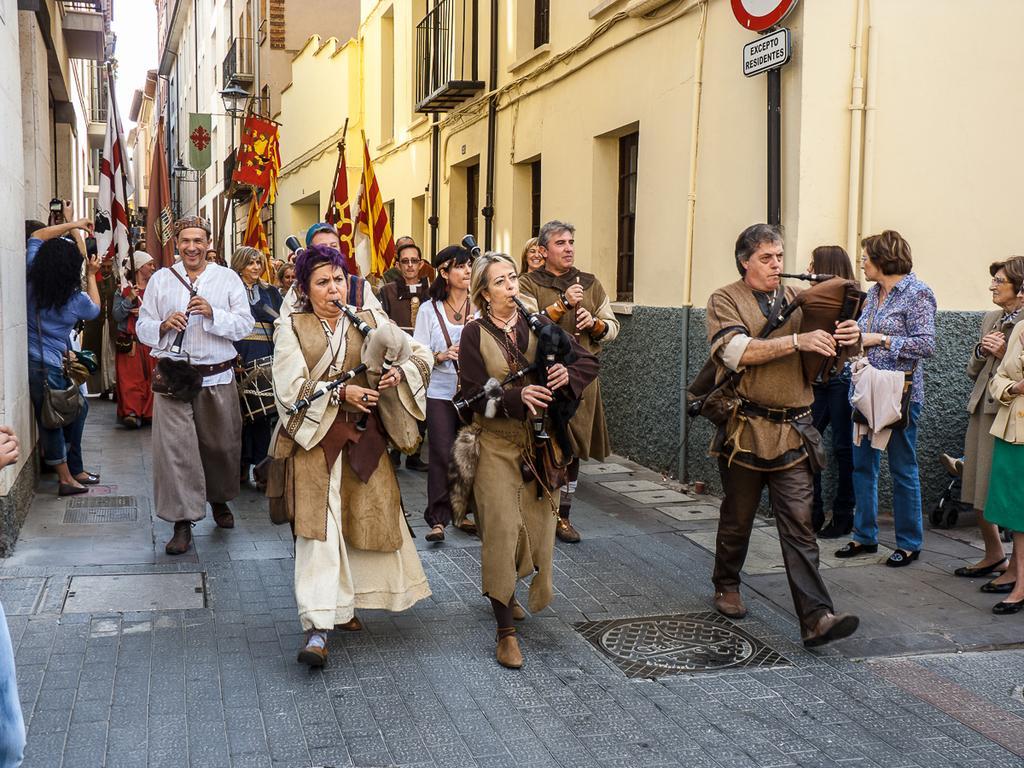Please provide a concise description of this image. There is a group of people playing musical instruments as we can see in the middle of this image. There is a group of people standing on the right side of this image and there are buildings in the background. 